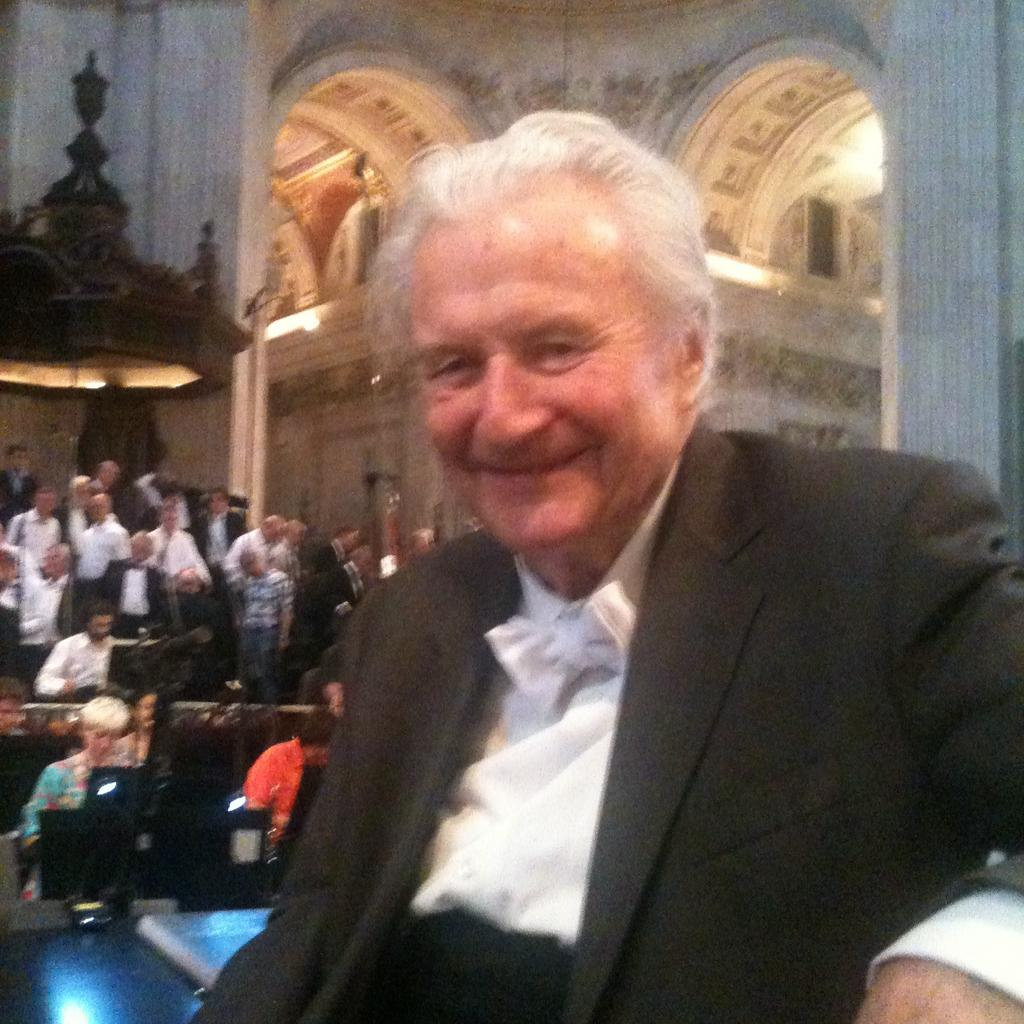What is the main subject in the foreground of the picture? There is a man in the foreground of the picture. What is the man wearing? The man is wearing a black suit. What expression does the man have on his face? The man has a smile on his face. What can be seen in the background of the picture? There is a crowd and a wall visible in the background of the picture. What type of liquid is being rewarded to the man in the picture? There is no liquid or reward being given to the man in the picture; he is simply smiling in the foreground. 